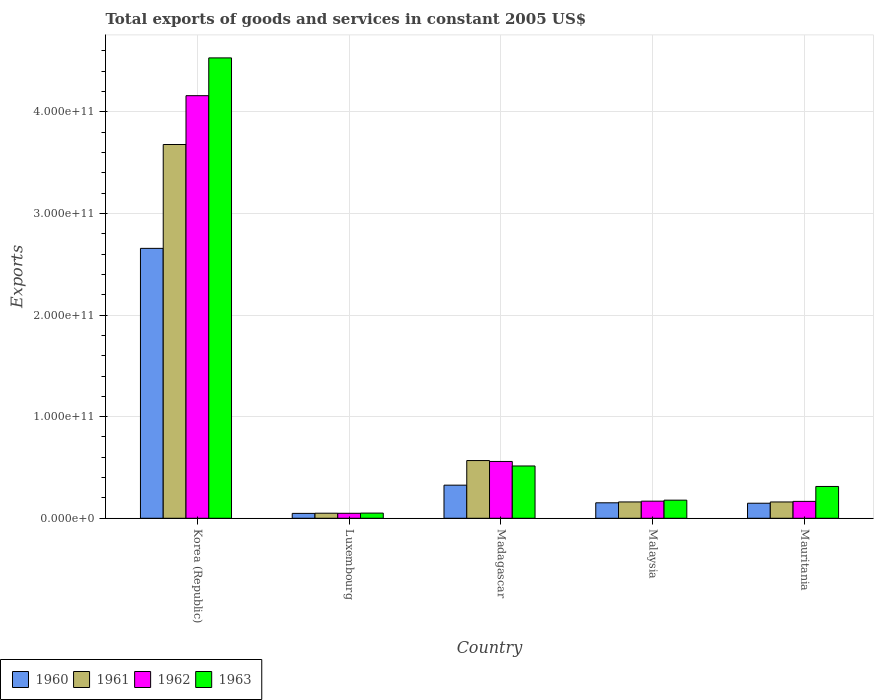Are the number of bars on each tick of the X-axis equal?
Provide a short and direct response. Yes. What is the label of the 3rd group of bars from the left?
Offer a terse response. Madagascar. In how many cases, is the number of bars for a given country not equal to the number of legend labels?
Make the answer very short. 0. What is the total exports of goods and services in 1960 in Mauritania?
Make the answer very short. 1.48e+1. Across all countries, what is the maximum total exports of goods and services in 1961?
Give a very brief answer. 3.68e+11. Across all countries, what is the minimum total exports of goods and services in 1960?
Offer a terse response. 4.81e+09. In which country was the total exports of goods and services in 1962 minimum?
Offer a very short reply. Luxembourg. What is the total total exports of goods and services in 1961 in the graph?
Your answer should be compact. 4.62e+11. What is the difference between the total exports of goods and services in 1962 in Madagascar and that in Mauritania?
Offer a terse response. 3.93e+1. What is the difference between the total exports of goods and services in 1962 in Luxembourg and the total exports of goods and services in 1961 in Mauritania?
Make the answer very short. -1.12e+1. What is the average total exports of goods and services in 1962 per country?
Ensure brevity in your answer.  1.02e+11. What is the difference between the total exports of goods and services of/in 1960 and total exports of goods and services of/in 1962 in Malaysia?
Your answer should be very brief. -1.61e+09. In how many countries, is the total exports of goods and services in 1962 greater than 200000000000 US$?
Provide a short and direct response. 1. What is the ratio of the total exports of goods and services in 1961 in Korea (Republic) to that in Luxembourg?
Your answer should be very brief. 73.91. Is the total exports of goods and services in 1962 in Korea (Republic) less than that in Malaysia?
Offer a very short reply. No. What is the difference between the highest and the second highest total exports of goods and services in 1961?
Provide a short and direct response. 4.07e+1. What is the difference between the highest and the lowest total exports of goods and services in 1960?
Ensure brevity in your answer.  2.61e+11. In how many countries, is the total exports of goods and services in 1962 greater than the average total exports of goods and services in 1962 taken over all countries?
Give a very brief answer. 1. Is the sum of the total exports of goods and services in 1962 in Luxembourg and Malaysia greater than the maximum total exports of goods and services in 1960 across all countries?
Give a very brief answer. No. Is it the case that in every country, the sum of the total exports of goods and services in 1960 and total exports of goods and services in 1962 is greater than the sum of total exports of goods and services in 1963 and total exports of goods and services in 1961?
Your answer should be compact. No. What does the 1st bar from the left in Korea (Republic) represents?
Your answer should be compact. 1960. How many bars are there?
Offer a very short reply. 20. Are all the bars in the graph horizontal?
Offer a very short reply. No. How many countries are there in the graph?
Your answer should be very brief. 5. What is the difference between two consecutive major ticks on the Y-axis?
Your answer should be compact. 1.00e+11. Are the values on the major ticks of Y-axis written in scientific E-notation?
Your response must be concise. Yes. Does the graph contain any zero values?
Provide a short and direct response. No. What is the title of the graph?
Offer a terse response. Total exports of goods and services in constant 2005 US$. What is the label or title of the Y-axis?
Provide a succinct answer. Exports. What is the Exports of 1960 in Korea (Republic)?
Your answer should be very brief. 2.66e+11. What is the Exports of 1961 in Korea (Republic)?
Offer a very short reply. 3.68e+11. What is the Exports in 1962 in Korea (Republic)?
Your answer should be very brief. 4.16e+11. What is the Exports in 1963 in Korea (Republic)?
Make the answer very short. 4.53e+11. What is the Exports of 1960 in Luxembourg?
Make the answer very short. 4.81e+09. What is the Exports of 1961 in Luxembourg?
Make the answer very short. 4.98e+09. What is the Exports in 1962 in Luxembourg?
Offer a very short reply. 4.90e+09. What is the Exports in 1963 in Luxembourg?
Your answer should be compact. 5.08e+09. What is the Exports in 1960 in Madagascar?
Ensure brevity in your answer.  3.26e+1. What is the Exports of 1961 in Madagascar?
Your answer should be compact. 5.68e+1. What is the Exports of 1962 in Madagascar?
Offer a terse response. 5.59e+1. What is the Exports of 1963 in Madagascar?
Offer a terse response. 5.15e+1. What is the Exports in 1960 in Malaysia?
Offer a terse response. 1.52e+1. What is the Exports of 1961 in Malaysia?
Offer a terse response. 1.61e+1. What is the Exports in 1962 in Malaysia?
Make the answer very short. 1.68e+1. What is the Exports of 1963 in Malaysia?
Your response must be concise. 1.78e+1. What is the Exports in 1960 in Mauritania?
Make the answer very short. 1.48e+1. What is the Exports in 1961 in Mauritania?
Provide a succinct answer. 1.61e+1. What is the Exports in 1962 in Mauritania?
Offer a terse response. 1.66e+1. What is the Exports in 1963 in Mauritania?
Offer a terse response. 3.13e+1. Across all countries, what is the maximum Exports in 1960?
Make the answer very short. 2.66e+11. Across all countries, what is the maximum Exports of 1961?
Give a very brief answer. 3.68e+11. Across all countries, what is the maximum Exports of 1962?
Make the answer very short. 4.16e+11. Across all countries, what is the maximum Exports of 1963?
Offer a very short reply. 4.53e+11. Across all countries, what is the minimum Exports of 1960?
Keep it short and to the point. 4.81e+09. Across all countries, what is the minimum Exports of 1961?
Offer a terse response. 4.98e+09. Across all countries, what is the minimum Exports of 1962?
Your answer should be compact. 4.90e+09. Across all countries, what is the minimum Exports in 1963?
Give a very brief answer. 5.08e+09. What is the total Exports in 1960 in the graph?
Your answer should be very brief. 3.33e+11. What is the total Exports of 1961 in the graph?
Offer a very short reply. 4.62e+11. What is the total Exports in 1962 in the graph?
Ensure brevity in your answer.  5.10e+11. What is the total Exports of 1963 in the graph?
Provide a short and direct response. 5.59e+11. What is the difference between the Exports of 1960 in Korea (Republic) and that in Luxembourg?
Your response must be concise. 2.61e+11. What is the difference between the Exports in 1961 in Korea (Republic) and that in Luxembourg?
Your answer should be compact. 3.63e+11. What is the difference between the Exports in 1962 in Korea (Republic) and that in Luxembourg?
Your answer should be compact. 4.11e+11. What is the difference between the Exports in 1963 in Korea (Republic) and that in Luxembourg?
Make the answer very short. 4.48e+11. What is the difference between the Exports of 1960 in Korea (Republic) and that in Madagascar?
Your response must be concise. 2.33e+11. What is the difference between the Exports of 1961 in Korea (Republic) and that in Madagascar?
Your answer should be very brief. 3.11e+11. What is the difference between the Exports of 1962 in Korea (Republic) and that in Madagascar?
Provide a succinct answer. 3.60e+11. What is the difference between the Exports of 1963 in Korea (Republic) and that in Madagascar?
Your answer should be very brief. 4.02e+11. What is the difference between the Exports in 1960 in Korea (Republic) and that in Malaysia?
Your response must be concise. 2.50e+11. What is the difference between the Exports of 1961 in Korea (Republic) and that in Malaysia?
Your answer should be compact. 3.52e+11. What is the difference between the Exports of 1962 in Korea (Republic) and that in Malaysia?
Give a very brief answer. 3.99e+11. What is the difference between the Exports of 1963 in Korea (Republic) and that in Malaysia?
Offer a very short reply. 4.35e+11. What is the difference between the Exports of 1960 in Korea (Republic) and that in Mauritania?
Make the answer very short. 2.51e+11. What is the difference between the Exports of 1961 in Korea (Republic) and that in Mauritania?
Provide a short and direct response. 3.52e+11. What is the difference between the Exports in 1962 in Korea (Republic) and that in Mauritania?
Offer a terse response. 3.99e+11. What is the difference between the Exports of 1963 in Korea (Republic) and that in Mauritania?
Your answer should be compact. 4.22e+11. What is the difference between the Exports in 1960 in Luxembourg and that in Madagascar?
Provide a short and direct response. -2.78e+1. What is the difference between the Exports in 1961 in Luxembourg and that in Madagascar?
Ensure brevity in your answer.  -5.18e+1. What is the difference between the Exports of 1962 in Luxembourg and that in Madagascar?
Keep it short and to the point. -5.10e+1. What is the difference between the Exports in 1963 in Luxembourg and that in Madagascar?
Keep it short and to the point. -4.64e+1. What is the difference between the Exports in 1960 in Luxembourg and that in Malaysia?
Make the answer very short. -1.04e+1. What is the difference between the Exports of 1961 in Luxembourg and that in Malaysia?
Keep it short and to the point. -1.11e+1. What is the difference between the Exports of 1962 in Luxembourg and that in Malaysia?
Offer a terse response. -1.19e+1. What is the difference between the Exports of 1963 in Luxembourg and that in Malaysia?
Offer a very short reply. -1.27e+1. What is the difference between the Exports in 1960 in Luxembourg and that in Mauritania?
Ensure brevity in your answer.  -9.99e+09. What is the difference between the Exports of 1961 in Luxembourg and that in Mauritania?
Provide a succinct answer. -1.11e+1. What is the difference between the Exports in 1962 in Luxembourg and that in Mauritania?
Provide a succinct answer. -1.17e+1. What is the difference between the Exports in 1963 in Luxembourg and that in Mauritania?
Keep it short and to the point. -2.62e+1. What is the difference between the Exports of 1960 in Madagascar and that in Malaysia?
Keep it short and to the point. 1.74e+1. What is the difference between the Exports in 1961 in Madagascar and that in Malaysia?
Ensure brevity in your answer.  4.07e+1. What is the difference between the Exports in 1962 in Madagascar and that in Malaysia?
Keep it short and to the point. 3.91e+1. What is the difference between the Exports of 1963 in Madagascar and that in Malaysia?
Your answer should be very brief. 3.36e+1. What is the difference between the Exports in 1960 in Madagascar and that in Mauritania?
Provide a short and direct response. 1.78e+1. What is the difference between the Exports of 1961 in Madagascar and that in Mauritania?
Provide a short and direct response. 4.07e+1. What is the difference between the Exports of 1962 in Madagascar and that in Mauritania?
Keep it short and to the point. 3.93e+1. What is the difference between the Exports in 1963 in Madagascar and that in Mauritania?
Ensure brevity in your answer.  2.02e+1. What is the difference between the Exports of 1960 in Malaysia and that in Mauritania?
Your response must be concise. 4.22e+08. What is the difference between the Exports of 1961 in Malaysia and that in Mauritania?
Provide a short and direct response. 1.20e+07. What is the difference between the Exports of 1962 in Malaysia and that in Mauritania?
Your response must be concise. 2.15e+08. What is the difference between the Exports of 1963 in Malaysia and that in Mauritania?
Offer a terse response. -1.35e+1. What is the difference between the Exports of 1960 in Korea (Republic) and the Exports of 1961 in Luxembourg?
Ensure brevity in your answer.  2.61e+11. What is the difference between the Exports of 1960 in Korea (Republic) and the Exports of 1962 in Luxembourg?
Provide a short and direct response. 2.61e+11. What is the difference between the Exports in 1960 in Korea (Republic) and the Exports in 1963 in Luxembourg?
Ensure brevity in your answer.  2.61e+11. What is the difference between the Exports in 1961 in Korea (Republic) and the Exports in 1962 in Luxembourg?
Your answer should be very brief. 3.63e+11. What is the difference between the Exports of 1961 in Korea (Republic) and the Exports of 1963 in Luxembourg?
Keep it short and to the point. 3.63e+11. What is the difference between the Exports of 1962 in Korea (Republic) and the Exports of 1963 in Luxembourg?
Offer a very short reply. 4.11e+11. What is the difference between the Exports in 1960 in Korea (Republic) and the Exports in 1961 in Madagascar?
Provide a succinct answer. 2.09e+11. What is the difference between the Exports in 1960 in Korea (Republic) and the Exports in 1962 in Madagascar?
Give a very brief answer. 2.10e+11. What is the difference between the Exports of 1960 in Korea (Republic) and the Exports of 1963 in Madagascar?
Your response must be concise. 2.14e+11. What is the difference between the Exports of 1961 in Korea (Republic) and the Exports of 1962 in Madagascar?
Your answer should be compact. 3.12e+11. What is the difference between the Exports of 1961 in Korea (Republic) and the Exports of 1963 in Madagascar?
Ensure brevity in your answer.  3.16e+11. What is the difference between the Exports in 1962 in Korea (Republic) and the Exports in 1963 in Madagascar?
Ensure brevity in your answer.  3.64e+11. What is the difference between the Exports of 1960 in Korea (Republic) and the Exports of 1961 in Malaysia?
Your answer should be very brief. 2.50e+11. What is the difference between the Exports of 1960 in Korea (Republic) and the Exports of 1962 in Malaysia?
Your answer should be very brief. 2.49e+11. What is the difference between the Exports of 1960 in Korea (Republic) and the Exports of 1963 in Malaysia?
Your response must be concise. 2.48e+11. What is the difference between the Exports in 1961 in Korea (Republic) and the Exports in 1962 in Malaysia?
Make the answer very short. 3.51e+11. What is the difference between the Exports of 1961 in Korea (Republic) and the Exports of 1963 in Malaysia?
Ensure brevity in your answer.  3.50e+11. What is the difference between the Exports in 1962 in Korea (Republic) and the Exports in 1963 in Malaysia?
Give a very brief answer. 3.98e+11. What is the difference between the Exports of 1960 in Korea (Republic) and the Exports of 1961 in Mauritania?
Your answer should be compact. 2.50e+11. What is the difference between the Exports in 1960 in Korea (Republic) and the Exports in 1962 in Mauritania?
Keep it short and to the point. 2.49e+11. What is the difference between the Exports in 1960 in Korea (Republic) and the Exports in 1963 in Mauritania?
Your response must be concise. 2.34e+11. What is the difference between the Exports of 1961 in Korea (Republic) and the Exports of 1962 in Mauritania?
Give a very brief answer. 3.51e+11. What is the difference between the Exports in 1961 in Korea (Republic) and the Exports in 1963 in Mauritania?
Your response must be concise. 3.36e+11. What is the difference between the Exports of 1962 in Korea (Republic) and the Exports of 1963 in Mauritania?
Ensure brevity in your answer.  3.85e+11. What is the difference between the Exports in 1960 in Luxembourg and the Exports in 1961 in Madagascar?
Provide a short and direct response. -5.20e+1. What is the difference between the Exports of 1960 in Luxembourg and the Exports of 1962 in Madagascar?
Provide a succinct answer. -5.11e+1. What is the difference between the Exports in 1960 in Luxembourg and the Exports in 1963 in Madagascar?
Your response must be concise. -4.67e+1. What is the difference between the Exports of 1961 in Luxembourg and the Exports of 1962 in Madagascar?
Make the answer very short. -5.09e+1. What is the difference between the Exports in 1961 in Luxembourg and the Exports in 1963 in Madagascar?
Your answer should be very brief. -4.65e+1. What is the difference between the Exports in 1962 in Luxembourg and the Exports in 1963 in Madagascar?
Ensure brevity in your answer.  -4.66e+1. What is the difference between the Exports in 1960 in Luxembourg and the Exports in 1961 in Malaysia?
Keep it short and to the point. -1.13e+1. What is the difference between the Exports of 1960 in Luxembourg and the Exports of 1962 in Malaysia?
Ensure brevity in your answer.  -1.20e+1. What is the difference between the Exports in 1960 in Luxembourg and the Exports in 1963 in Malaysia?
Your answer should be compact. -1.30e+1. What is the difference between the Exports in 1961 in Luxembourg and the Exports in 1962 in Malaysia?
Your answer should be very brief. -1.19e+1. What is the difference between the Exports in 1961 in Luxembourg and the Exports in 1963 in Malaysia?
Offer a very short reply. -1.28e+1. What is the difference between the Exports in 1962 in Luxembourg and the Exports in 1963 in Malaysia?
Provide a succinct answer. -1.29e+1. What is the difference between the Exports of 1960 in Luxembourg and the Exports of 1961 in Mauritania?
Give a very brief answer. -1.12e+1. What is the difference between the Exports of 1960 in Luxembourg and the Exports of 1962 in Mauritania?
Give a very brief answer. -1.18e+1. What is the difference between the Exports of 1960 in Luxembourg and the Exports of 1963 in Mauritania?
Your answer should be very brief. -2.65e+1. What is the difference between the Exports in 1961 in Luxembourg and the Exports in 1962 in Mauritania?
Your answer should be compact. -1.16e+1. What is the difference between the Exports of 1961 in Luxembourg and the Exports of 1963 in Mauritania?
Your answer should be compact. -2.63e+1. What is the difference between the Exports of 1962 in Luxembourg and the Exports of 1963 in Mauritania?
Provide a succinct answer. -2.64e+1. What is the difference between the Exports of 1960 in Madagascar and the Exports of 1961 in Malaysia?
Offer a terse response. 1.65e+1. What is the difference between the Exports in 1960 in Madagascar and the Exports in 1962 in Malaysia?
Your response must be concise. 1.57e+1. What is the difference between the Exports of 1960 in Madagascar and the Exports of 1963 in Malaysia?
Your answer should be very brief. 1.48e+1. What is the difference between the Exports of 1961 in Madagascar and the Exports of 1962 in Malaysia?
Give a very brief answer. 4.00e+1. What is the difference between the Exports of 1961 in Madagascar and the Exports of 1963 in Malaysia?
Your response must be concise. 3.90e+1. What is the difference between the Exports of 1962 in Madagascar and the Exports of 1963 in Malaysia?
Provide a short and direct response. 3.81e+1. What is the difference between the Exports in 1960 in Madagascar and the Exports in 1961 in Mauritania?
Offer a very short reply. 1.65e+1. What is the difference between the Exports in 1960 in Madagascar and the Exports in 1962 in Mauritania?
Make the answer very short. 1.60e+1. What is the difference between the Exports of 1960 in Madagascar and the Exports of 1963 in Mauritania?
Provide a short and direct response. 1.27e+09. What is the difference between the Exports of 1961 in Madagascar and the Exports of 1962 in Mauritania?
Provide a short and direct response. 4.02e+1. What is the difference between the Exports of 1961 in Madagascar and the Exports of 1963 in Mauritania?
Offer a terse response. 2.55e+1. What is the difference between the Exports of 1962 in Madagascar and the Exports of 1963 in Mauritania?
Make the answer very short. 2.46e+1. What is the difference between the Exports of 1960 in Malaysia and the Exports of 1961 in Mauritania?
Provide a succinct answer. -8.31e+08. What is the difference between the Exports in 1960 in Malaysia and the Exports in 1962 in Mauritania?
Keep it short and to the point. -1.40e+09. What is the difference between the Exports of 1960 in Malaysia and the Exports of 1963 in Mauritania?
Offer a very short reply. -1.61e+1. What is the difference between the Exports in 1961 in Malaysia and the Exports in 1962 in Mauritania?
Your response must be concise. -5.57e+08. What is the difference between the Exports of 1961 in Malaysia and the Exports of 1963 in Mauritania?
Keep it short and to the point. -1.52e+1. What is the difference between the Exports in 1962 in Malaysia and the Exports in 1963 in Mauritania?
Offer a very short reply. -1.45e+1. What is the average Exports of 1960 per country?
Provide a succinct answer. 6.66e+1. What is the average Exports in 1961 per country?
Ensure brevity in your answer.  9.23e+1. What is the average Exports of 1962 per country?
Your answer should be very brief. 1.02e+11. What is the average Exports of 1963 per country?
Provide a short and direct response. 1.12e+11. What is the difference between the Exports in 1960 and Exports in 1961 in Korea (Republic)?
Ensure brevity in your answer.  -1.02e+11. What is the difference between the Exports of 1960 and Exports of 1962 in Korea (Republic)?
Your answer should be compact. -1.50e+11. What is the difference between the Exports in 1960 and Exports in 1963 in Korea (Republic)?
Offer a terse response. -1.87e+11. What is the difference between the Exports in 1961 and Exports in 1962 in Korea (Republic)?
Offer a very short reply. -4.81e+1. What is the difference between the Exports of 1961 and Exports of 1963 in Korea (Republic)?
Make the answer very short. -8.52e+1. What is the difference between the Exports of 1962 and Exports of 1963 in Korea (Republic)?
Provide a succinct answer. -3.72e+1. What is the difference between the Exports of 1960 and Exports of 1961 in Luxembourg?
Offer a terse response. -1.68e+08. What is the difference between the Exports in 1960 and Exports in 1962 in Luxembourg?
Offer a very short reply. -8.82e+07. What is the difference between the Exports in 1960 and Exports in 1963 in Luxembourg?
Ensure brevity in your answer.  -2.73e+08. What is the difference between the Exports in 1961 and Exports in 1962 in Luxembourg?
Your answer should be compact. 7.94e+07. What is the difference between the Exports in 1961 and Exports in 1963 in Luxembourg?
Keep it short and to the point. -1.05e+08. What is the difference between the Exports in 1962 and Exports in 1963 in Luxembourg?
Your answer should be compact. -1.85e+08. What is the difference between the Exports in 1960 and Exports in 1961 in Madagascar?
Offer a terse response. -2.42e+1. What is the difference between the Exports of 1960 and Exports of 1962 in Madagascar?
Keep it short and to the point. -2.33e+1. What is the difference between the Exports in 1960 and Exports in 1963 in Madagascar?
Ensure brevity in your answer.  -1.89e+1. What is the difference between the Exports in 1961 and Exports in 1962 in Madagascar?
Keep it short and to the point. 8.87e+08. What is the difference between the Exports of 1961 and Exports of 1963 in Madagascar?
Provide a succinct answer. 5.32e+09. What is the difference between the Exports in 1962 and Exports in 1963 in Madagascar?
Make the answer very short. 4.44e+09. What is the difference between the Exports of 1960 and Exports of 1961 in Malaysia?
Provide a succinct answer. -8.42e+08. What is the difference between the Exports in 1960 and Exports in 1962 in Malaysia?
Offer a very short reply. -1.61e+09. What is the difference between the Exports of 1960 and Exports of 1963 in Malaysia?
Provide a succinct answer. -2.60e+09. What is the difference between the Exports in 1961 and Exports in 1962 in Malaysia?
Offer a very short reply. -7.72e+08. What is the difference between the Exports of 1961 and Exports of 1963 in Malaysia?
Offer a very short reply. -1.76e+09. What is the difference between the Exports in 1962 and Exports in 1963 in Malaysia?
Make the answer very short. -9.85e+08. What is the difference between the Exports in 1960 and Exports in 1961 in Mauritania?
Offer a very short reply. -1.25e+09. What is the difference between the Exports of 1960 and Exports of 1962 in Mauritania?
Your answer should be very brief. -1.82e+09. What is the difference between the Exports in 1960 and Exports in 1963 in Mauritania?
Your response must be concise. -1.65e+1. What is the difference between the Exports in 1961 and Exports in 1962 in Mauritania?
Give a very brief answer. -5.69e+08. What is the difference between the Exports in 1961 and Exports in 1963 in Mauritania?
Give a very brief answer. -1.53e+1. What is the difference between the Exports in 1962 and Exports in 1963 in Mauritania?
Give a very brief answer. -1.47e+1. What is the ratio of the Exports of 1960 in Korea (Republic) to that in Luxembourg?
Your response must be concise. 55.23. What is the ratio of the Exports in 1961 in Korea (Republic) to that in Luxembourg?
Make the answer very short. 73.91. What is the ratio of the Exports in 1962 in Korea (Republic) to that in Luxembourg?
Offer a very short reply. 84.92. What is the ratio of the Exports of 1963 in Korea (Republic) to that in Luxembourg?
Your answer should be very brief. 89.15. What is the ratio of the Exports of 1960 in Korea (Republic) to that in Madagascar?
Your answer should be compact. 8.15. What is the ratio of the Exports in 1961 in Korea (Republic) to that in Madagascar?
Your answer should be compact. 6.48. What is the ratio of the Exports in 1962 in Korea (Republic) to that in Madagascar?
Offer a very short reply. 7.44. What is the ratio of the Exports of 1963 in Korea (Republic) to that in Madagascar?
Offer a very short reply. 8.8. What is the ratio of the Exports of 1960 in Korea (Republic) to that in Malaysia?
Keep it short and to the point. 17.45. What is the ratio of the Exports in 1961 in Korea (Republic) to that in Malaysia?
Offer a very short reply. 22.9. What is the ratio of the Exports in 1962 in Korea (Republic) to that in Malaysia?
Keep it short and to the point. 24.7. What is the ratio of the Exports in 1963 in Korea (Republic) to that in Malaysia?
Ensure brevity in your answer.  25.42. What is the ratio of the Exports in 1960 in Korea (Republic) to that in Mauritania?
Provide a short and direct response. 17.95. What is the ratio of the Exports in 1961 in Korea (Republic) to that in Mauritania?
Offer a very short reply. 22.91. What is the ratio of the Exports of 1962 in Korea (Republic) to that in Mauritania?
Your answer should be very brief. 25.02. What is the ratio of the Exports of 1963 in Korea (Republic) to that in Mauritania?
Give a very brief answer. 14.47. What is the ratio of the Exports in 1960 in Luxembourg to that in Madagascar?
Give a very brief answer. 0.15. What is the ratio of the Exports of 1961 in Luxembourg to that in Madagascar?
Your response must be concise. 0.09. What is the ratio of the Exports of 1962 in Luxembourg to that in Madagascar?
Provide a short and direct response. 0.09. What is the ratio of the Exports in 1963 in Luxembourg to that in Madagascar?
Your answer should be very brief. 0.1. What is the ratio of the Exports of 1960 in Luxembourg to that in Malaysia?
Keep it short and to the point. 0.32. What is the ratio of the Exports in 1961 in Luxembourg to that in Malaysia?
Offer a very short reply. 0.31. What is the ratio of the Exports of 1962 in Luxembourg to that in Malaysia?
Your answer should be very brief. 0.29. What is the ratio of the Exports of 1963 in Luxembourg to that in Malaysia?
Make the answer very short. 0.29. What is the ratio of the Exports in 1960 in Luxembourg to that in Mauritania?
Your answer should be very brief. 0.32. What is the ratio of the Exports in 1961 in Luxembourg to that in Mauritania?
Your response must be concise. 0.31. What is the ratio of the Exports of 1962 in Luxembourg to that in Mauritania?
Provide a succinct answer. 0.29. What is the ratio of the Exports of 1963 in Luxembourg to that in Mauritania?
Your answer should be compact. 0.16. What is the ratio of the Exports of 1960 in Madagascar to that in Malaysia?
Give a very brief answer. 2.14. What is the ratio of the Exports of 1961 in Madagascar to that in Malaysia?
Make the answer very short. 3.54. What is the ratio of the Exports in 1962 in Madagascar to that in Malaysia?
Ensure brevity in your answer.  3.32. What is the ratio of the Exports in 1963 in Madagascar to that in Malaysia?
Your answer should be compact. 2.89. What is the ratio of the Exports of 1960 in Madagascar to that in Mauritania?
Offer a terse response. 2.2. What is the ratio of the Exports of 1961 in Madagascar to that in Mauritania?
Keep it short and to the point. 3.54. What is the ratio of the Exports in 1962 in Madagascar to that in Mauritania?
Keep it short and to the point. 3.36. What is the ratio of the Exports in 1963 in Madagascar to that in Mauritania?
Provide a short and direct response. 1.64. What is the ratio of the Exports of 1960 in Malaysia to that in Mauritania?
Offer a very short reply. 1.03. What is the ratio of the Exports in 1961 in Malaysia to that in Mauritania?
Give a very brief answer. 1. What is the ratio of the Exports of 1962 in Malaysia to that in Mauritania?
Provide a short and direct response. 1.01. What is the ratio of the Exports of 1963 in Malaysia to that in Mauritania?
Offer a terse response. 0.57. What is the difference between the highest and the second highest Exports of 1960?
Make the answer very short. 2.33e+11. What is the difference between the highest and the second highest Exports in 1961?
Your answer should be compact. 3.11e+11. What is the difference between the highest and the second highest Exports in 1962?
Offer a terse response. 3.60e+11. What is the difference between the highest and the second highest Exports in 1963?
Ensure brevity in your answer.  4.02e+11. What is the difference between the highest and the lowest Exports of 1960?
Keep it short and to the point. 2.61e+11. What is the difference between the highest and the lowest Exports of 1961?
Ensure brevity in your answer.  3.63e+11. What is the difference between the highest and the lowest Exports in 1962?
Keep it short and to the point. 4.11e+11. What is the difference between the highest and the lowest Exports in 1963?
Your response must be concise. 4.48e+11. 